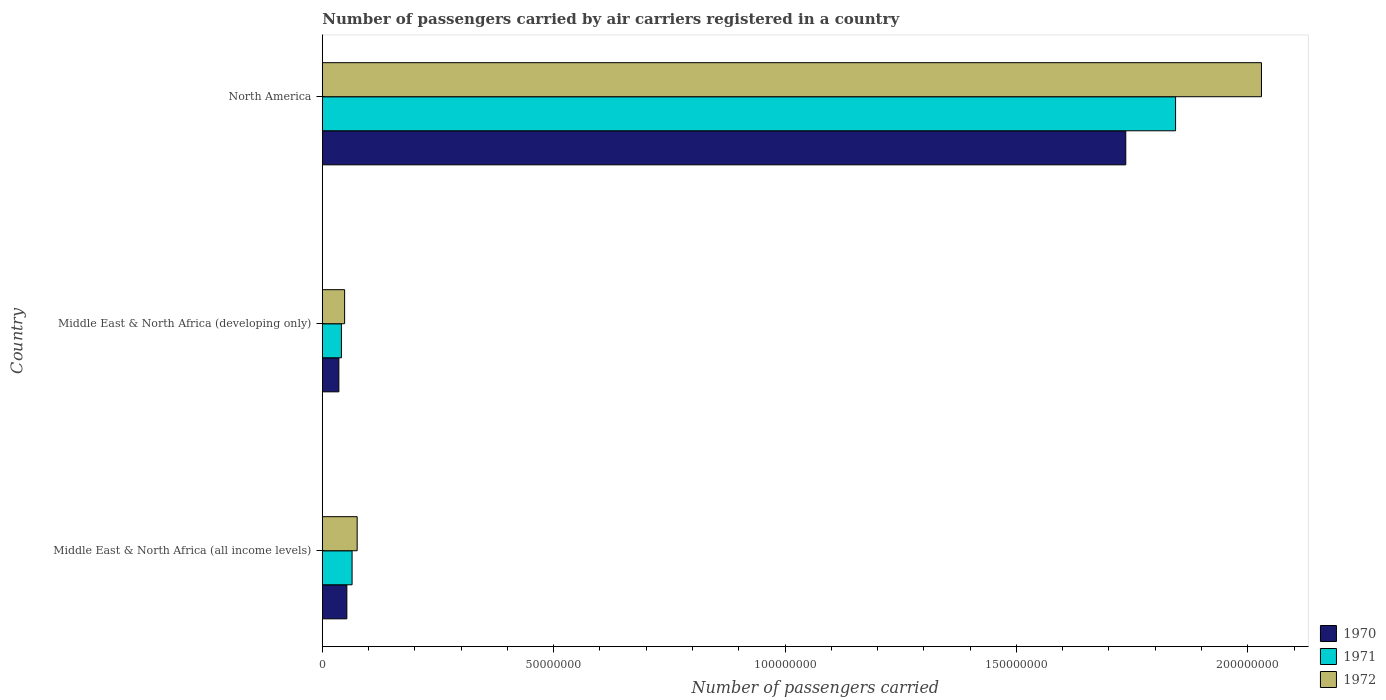How many different coloured bars are there?
Give a very brief answer. 3. How many groups of bars are there?
Your response must be concise. 3. Are the number of bars on each tick of the Y-axis equal?
Offer a terse response. Yes. How many bars are there on the 3rd tick from the top?
Your answer should be compact. 3. How many bars are there on the 3rd tick from the bottom?
Ensure brevity in your answer.  3. What is the label of the 3rd group of bars from the top?
Offer a terse response. Middle East & North Africa (all income levels). In how many cases, is the number of bars for a given country not equal to the number of legend labels?
Offer a terse response. 0. What is the number of passengers carried by air carriers in 1971 in Middle East & North Africa (all income levels)?
Provide a succinct answer. 6.43e+06. Across all countries, what is the maximum number of passengers carried by air carriers in 1972?
Offer a very short reply. 2.03e+08. Across all countries, what is the minimum number of passengers carried by air carriers in 1970?
Give a very brief answer. 3.58e+06. In which country was the number of passengers carried by air carriers in 1971 maximum?
Your answer should be very brief. North America. In which country was the number of passengers carried by air carriers in 1970 minimum?
Your response must be concise. Middle East & North Africa (developing only). What is the total number of passengers carried by air carriers in 1972 in the graph?
Keep it short and to the point. 2.15e+08. What is the difference between the number of passengers carried by air carriers in 1972 in Middle East & North Africa (developing only) and that in North America?
Keep it short and to the point. -1.98e+08. What is the difference between the number of passengers carried by air carriers in 1972 in North America and the number of passengers carried by air carriers in 1970 in Middle East & North Africa (all income levels)?
Provide a succinct answer. 1.98e+08. What is the average number of passengers carried by air carriers in 1971 per country?
Ensure brevity in your answer.  6.50e+07. What is the difference between the number of passengers carried by air carriers in 1970 and number of passengers carried by air carriers in 1971 in Middle East & North Africa (developing only)?
Make the answer very short. -5.49e+05. In how many countries, is the number of passengers carried by air carriers in 1972 greater than 150000000 ?
Offer a terse response. 1. What is the ratio of the number of passengers carried by air carriers in 1971 in Middle East & North Africa (developing only) to that in North America?
Give a very brief answer. 0.02. What is the difference between the highest and the second highest number of passengers carried by air carriers in 1972?
Ensure brevity in your answer.  1.95e+08. What is the difference between the highest and the lowest number of passengers carried by air carriers in 1972?
Provide a succinct answer. 1.98e+08. Is the sum of the number of passengers carried by air carriers in 1970 in Middle East & North Africa (all income levels) and Middle East & North Africa (developing only) greater than the maximum number of passengers carried by air carriers in 1971 across all countries?
Make the answer very short. No. How many bars are there?
Give a very brief answer. 9. Are all the bars in the graph horizontal?
Offer a very short reply. Yes. How many countries are there in the graph?
Offer a terse response. 3. Does the graph contain grids?
Your answer should be very brief. No. Where does the legend appear in the graph?
Offer a terse response. Bottom right. How many legend labels are there?
Provide a succinct answer. 3. What is the title of the graph?
Keep it short and to the point. Number of passengers carried by air carriers registered in a country. What is the label or title of the X-axis?
Your answer should be very brief. Number of passengers carried. What is the Number of passengers carried of 1970 in Middle East & North Africa (all income levels)?
Keep it short and to the point. 5.30e+06. What is the Number of passengers carried of 1971 in Middle East & North Africa (all income levels)?
Offer a terse response. 6.43e+06. What is the Number of passengers carried of 1972 in Middle East & North Africa (all income levels)?
Offer a terse response. 7.53e+06. What is the Number of passengers carried in 1970 in Middle East & North Africa (developing only)?
Your response must be concise. 3.58e+06. What is the Number of passengers carried in 1971 in Middle East & North Africa (developing only)?
Your answer should be very brief. 4.12e+06. What is the Number of passengers carried in 1972 in Middle East & North Africa (developing only)?
Provide a succinct answer. 4.82e+06. What is the Number of passengers carried of 1970 in North America?
Offer a very short reply. 1.74e+08. What is the Number of passengers carried in 1971 in North America?
Your answer should be very brief. 1.84e+08. What is the Number of passengers carried in 1972 in North America?
Make the answer very short. 2.03e+08. Across all countries, what is the maximum Number of passengers carried in 1970?
Ensure brevity in your answer.  1.74e+08. Across all countries, what is the maximum Number of passengers carried of 1971?
Provide a succinct answer. 1.84e+08. Across all countries, what is the maximum Number of passengers carried of 1972?
Give a very brief answer. 2.03e+08. Across all countries, what is the minimum Number of passengers carried of 1970?
Keep it short and to the point. 3.58e+06. Across all countries, what is the minimum Number of passengers carried in 1971?
Offer a terse response. 4.12e+06. Across all countries, what is the minimum Number of passengers carried in 1972?
Your answer should be very brief. 4.82e+06. What is the total Number of passengers carried of 1970 in the graph?
Give a very brief answer. 1.83e+08. What is the total Number of passengers carried of 1971 in the graph?
Give a very brief answer. 1.95e+08. What is the total Number of passengers carried in 1972 in the graph?
Ensure brevity in your answer.  2.15e+08. What is the difference between the Number of passengers carried in 1970 in Middle East & North Africa (all income levels) and that in Middle East & North Africa (developing only)?
Provide a short and direct response. 1.73e+06. What is the difference between the Number of passengers carried in 1971 in Middle East & North Africa (all income levels) and that in Middle East & North Africa (developing only)?
Offer a very short reply. 2.30e+06. What is the difference between the Number of passengers carried of 1972 in Middle East & North Africa (all income levels) and that in Middle East & North Africa (developing only)?
Your response must be concise. 2.71e+06. What is the difference between the Number of passengers carried in 1970 in Middle East & North Africa (all income levels) and that in North America?
Provide a succinct answer. -1.68e+08. What is the difference between the Number of passengers carried of 1971 in Middle East & North Africa (all income levels) and that in North America?
Provide a short and direct response. -1.78e+08. What is the difference between the Number of passengers carried of 1972 in Middle East & North Africa (all income levels) and that in North America?
Offer a terse response. -1.95e+08. What is the difference between the Number of passengers carried in 1970 in Middle East & North Africa (developing only) and that in North America?
Provide a short and direct response. -1.70e+08. What is the difference between the Number of passengers carried of 1971 in Middle East & North Africa (developing only) and that in North America?
Provide a short and direct response. -1.80e+08. What is the difference between the Number of passengers carried in 1972 in Middle East & North Africa (developing only) and that in North America?
Give a very brief answer. -1.98e+08. What is the difference between the Number of passengers carried of 1970 in Middle East & North Africa (all income levels) and the Number of passengers carried of 1971 in Middle East & North Africa (developing only)?
Provide a succinct answer. 1.18e+06. What is the difference between the Number of passengers carried of 1970 in Middle East & North Africa (all income levels) and the Number of passengers carried of 1972 in Middle East & North Africa (developing only)?
Keep it short and to the point. 4.86e+05. What is the difference between the Number of passengers carried in 1971 in Middle East & North Africa (all income levels) and the Number of passengers carried in 1972 in Middle East & North Africa (developing only)?
Your answer should be compact. 1.61e+06. What is the difference between the Number of passengers carried in 1970 in Middle East & North Africa (all income levels) and the Number of passengers carried in 1971 in North America?
Keep it short and to the point. -1.79e+08. What is the difference between the Number of passengers carried in 1970 in Middle East & North Africa (all income levels) and the Number of passengers carried in 1972 in North America?
Keep it short and to the point. -1.98e+08. What is the difference between the Number of passengers carried in 1971 in Middle East & North Africa (all income levels) and the Number of passengers carried in 1972 in North America?
Offer a terse response. -1.97e+08. What is the difference between the Number of passengers carried in 1970 in Middle East & North Africa (developing only) and the Number of passengers carried in 1971 in North America?
Make the answer very short. -1.81e+08. What is the difference between the Number of passengers carried of 1970 in Middle East & North Africa (developing only) and the Number of passengers carried of 1972 in North America?
Offer a terse response. -1.99e+08. What is the difference between the Number of passengers carried of 1971 in Middle East & North Africa (developing only) and the Number of passengers carried of 1972 in North America?
Offer a terse response. -1.99e+08. What is the average Number of passengers carried of 1970 per country?
Give a very brief answer. 6.08e+07. What is the average Number of passengers carried in 1971 per country?
Provide a succinct answer. 6.50e+07. What is the average Number of passengers carried in 1972 per country?
Keep it short and to the point. 7.18e+07. What is the difference between the Number of passengers carried in 1970 and Number of passengers carried in 1971 in Middle East & North Africa (all income levels)?
Keep it short and to the point. -1.13e+06. What is the difference between the Number of passengers carried in 1970 and Number of passengers carried in 1972 in Middle East & North Africa (all income levels)?
Ensure brevity in your answer.  -2.23e+06. What is the difference between the Number of passengers carried in 1971 and Number of passengers carried in 1972 in Middle East & North Africa (all income levels)?
Your response must be concise. -1.10e+06. What is the difference between the Number of passengers carried of 1970 and Number of passengers carried of 1971 in Middle East & North Africa (developing only)?
Provide a succinct answer. -5.49e+05. What is the difference between the Number of passengers carried in 1970 and Number of passengers carried in 1972 in Middle East & North Africa (developing only)?
Offer a terse response. -1.24e+06. What is the difference between the Number of passengers carried of 1971 and Number of passengers carried of 1972 in Middle East & North Africa (developing only)?
Offer a very short reply. -6.92e+05. What is the difference between the Number of passengers carried of 1970 and Number of passengers carried of 1971 in North America?
Your answer should be very brief. -1.08e+07. What is the difference between the Number of passengers carried in 1970 and Number of passengers carried in 1972 in North America?
Your response must be concise. -2.93e+07. What is the difference between the Number of passengers carried of 1971 and Number of passengers carried of 1972 in North America?
Your answer should be very brief. -1.86e+07. What is the ratio of the Number of passengers carried in 1970 in Middle East & North Africa (all income levels) to that in Middle East & North Africa (developing only)?
Your answer should be compact. 1.48. What is the ratio of the Number of passengers carried in 1971 in Middle East & North Africa (all income levels) to that in Middle East & North Africa (developing only)?
Give a very brief answer. 1.56. What is the ratio of the Number of passengers carried of 1972 in Middle East & North Africa (all income levels) to that in Middle East & North Africa (developing only)?
Your answer should be compact. 1.56. What is the ratio of the Number of passengers carried of 1970 in Middle East & North Africa (all income levels) to that in North America?
Keep it short and to the point. 0.03. What is the ratio of the Number of passengers carried in 1971 in Middle East & North Africa (all income levels) to that in North America?
Give a very brief answer. 0.03. What is the ratio of the Number of passengers carried of 1972 in Middle East & North Africa (all income levels) to that in North America?
Offer a very short reply. 0.04. What is the ratio of the Number of passengers carried of 1970 in Middle East & North Africa (developing only) to that in North America?
Offer a terse response. 0.02. What is the ratio of the Number of passengers carried in 1971 in Middle East & North Africa (developing only) to that in North America?
Offer a terse response. 0.02. What is the ratio of the Number of passengers carried of 1972 in Middle East & North Africa (developing only) to that in North America?
Your response must be concise. 0.02. What is the difference between the highest and the second highest Number of passengers carried in 1970?
Offer a very short reply. 1.68e+08. What is the difference between the highest and the second highest Number of passengers carried of 1971?
Your response must be concise. 1.78e+08. What is the difference between the highest and the second highest Number of passengers carried in 1972?
Provide a succinct answer. 1.95e+08. What is the difference between the highest and the lowest Number of passengers carried in 1970?
Provide a succinct answer. 1.70e+08. What is the difference between the highest and the lowest Number of passengers carried in 1971?
Offer a terse response. 1.80e+08. What is the difference between the highest and the lowest Number of passengers carried of 1972?
Your answer should be very brief. 1.98e+08. 